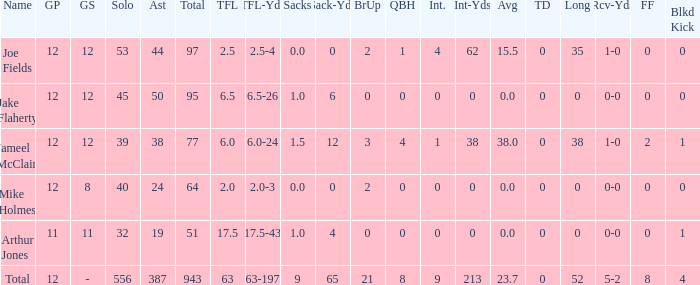How many yards for the player with tfl-yds of 2.5-4? 4-62. 